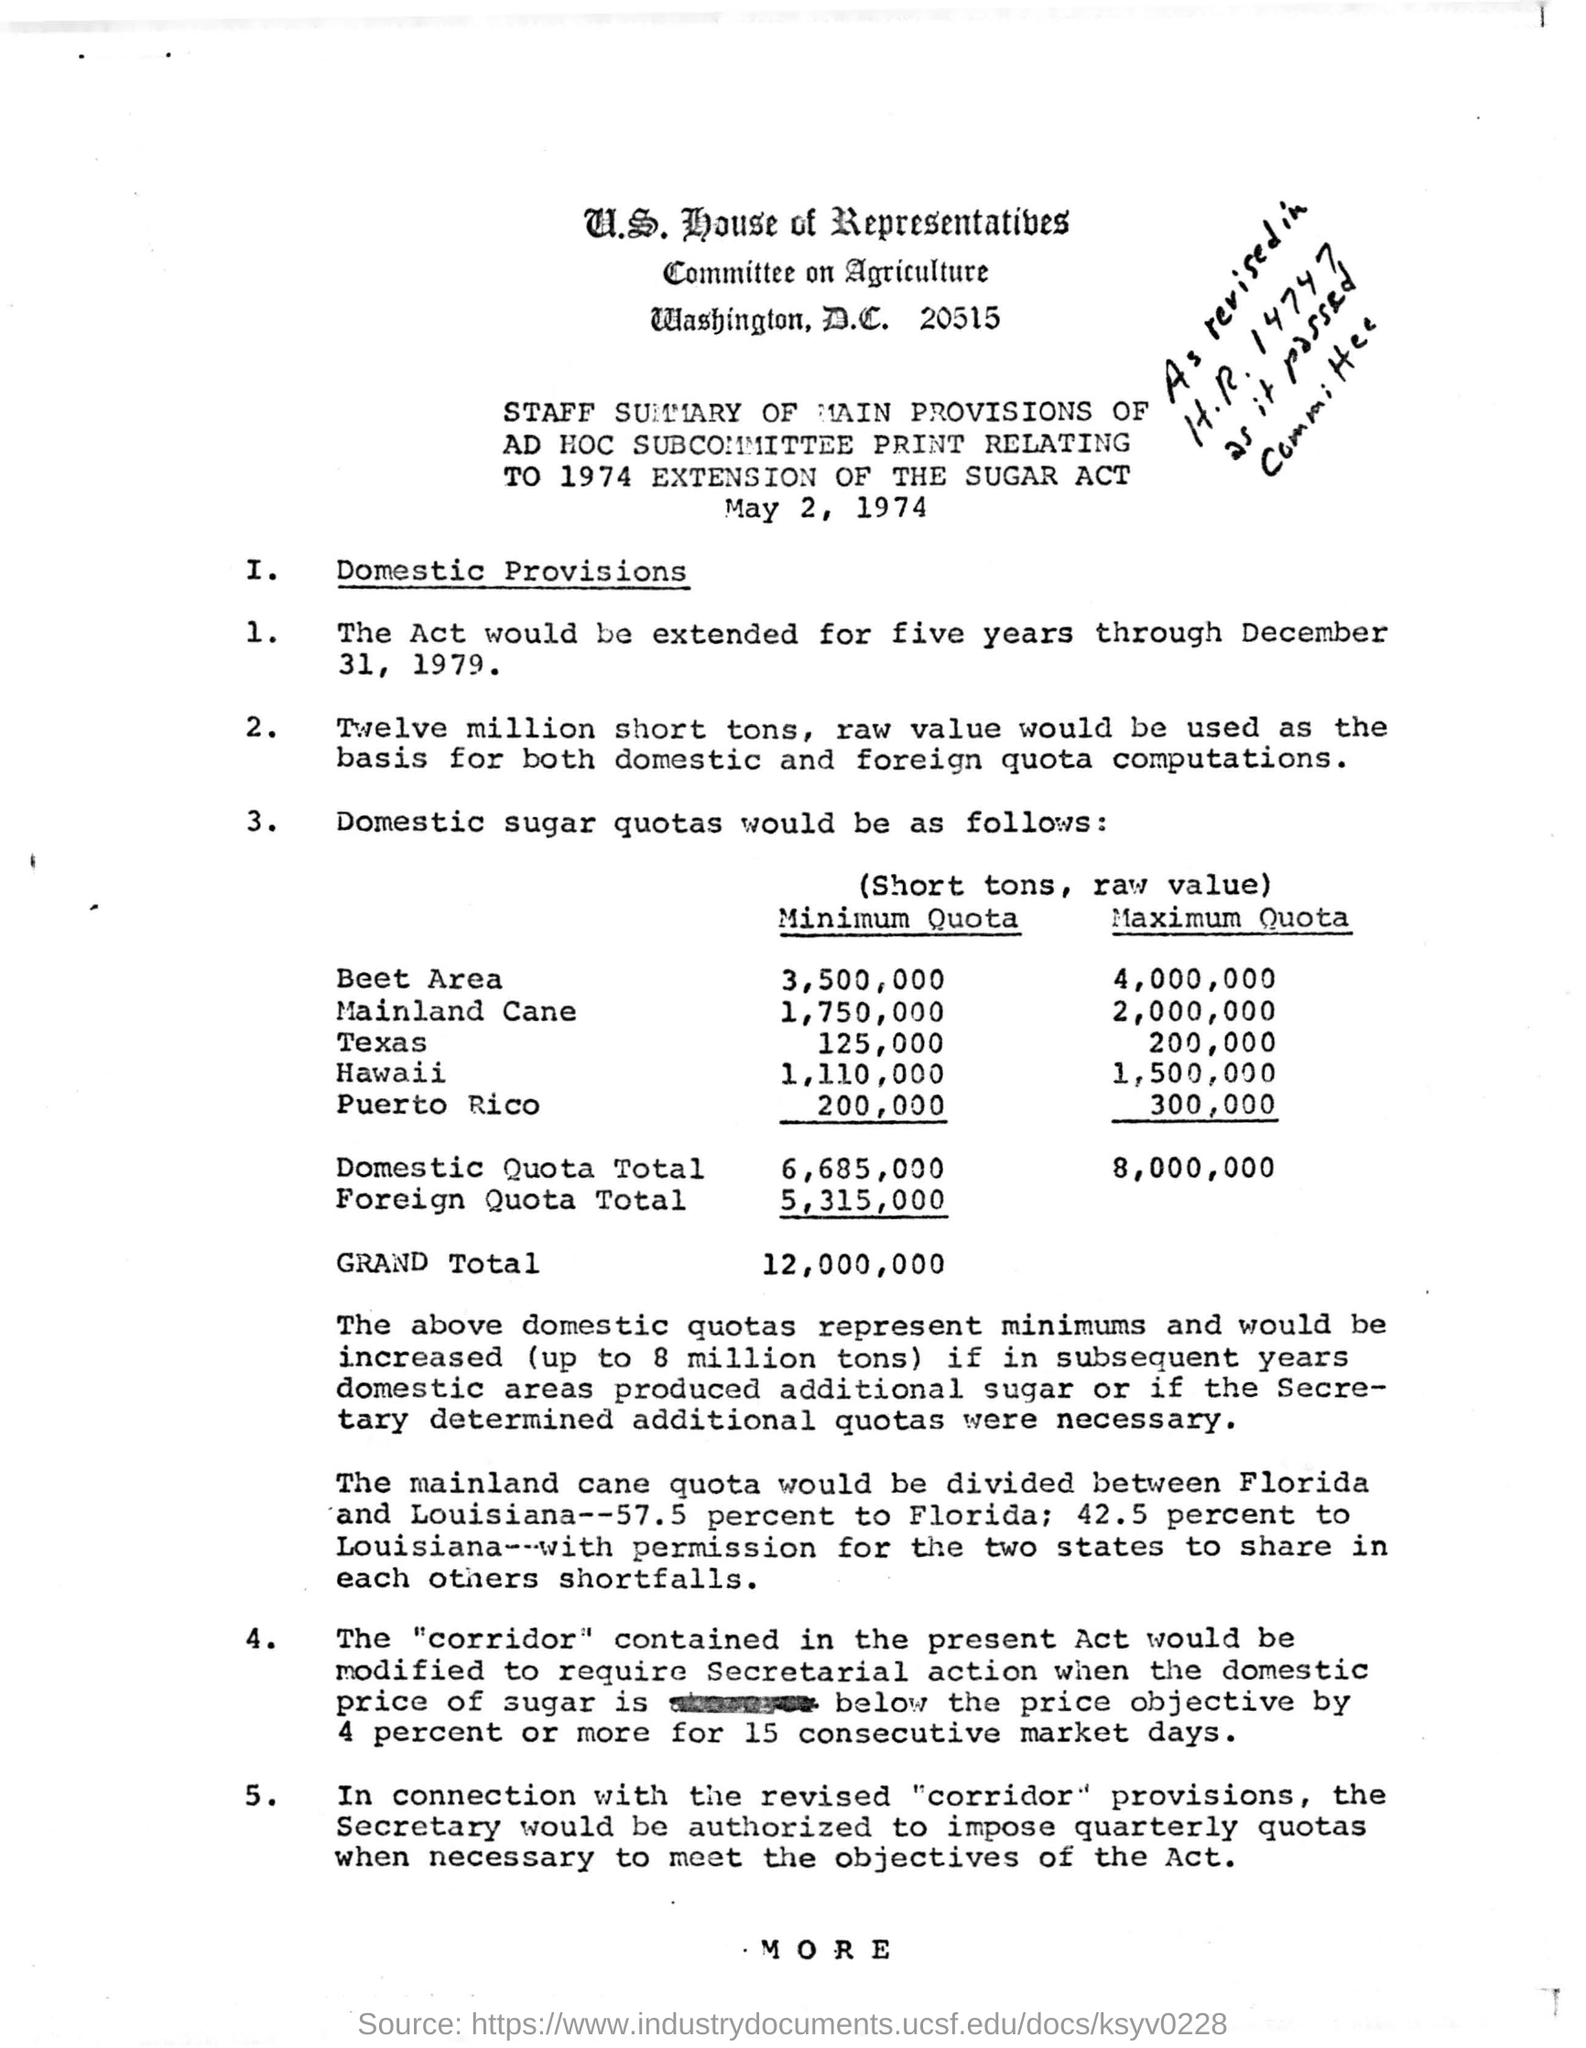What is the "minimum quota" for the "Beet Area"?
Ensure brevity in your answer.  3,500,000. What is the "maximum quota" for "Hawaii"?
Your answer should be very brief. 1,500,000. What is the "maximum quota" for "Mainland Cane"?
Provide a succinct answer. 2,000,000. What is the "minimum quota" for  "Texas"?
Keep it short and to the point. 125,000. 